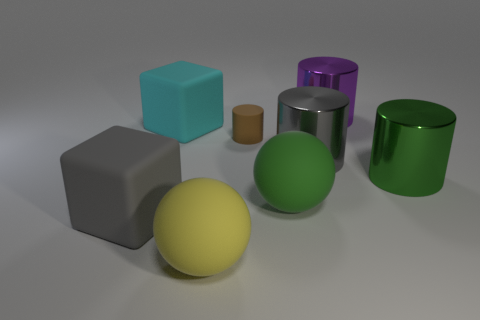Can you tell me the positions of the spheres relative to the cylinders? Certainly, the large green matte sphere is situated between the smaller brown cylinder and the large yellow matte sphere, forming a line of three objects. The large green metallic cylinder is to the right of the yellow sphere, and the large purple metallic cylinder is positioned to the right of the green sphere, but slightly behind it from this perspective. 